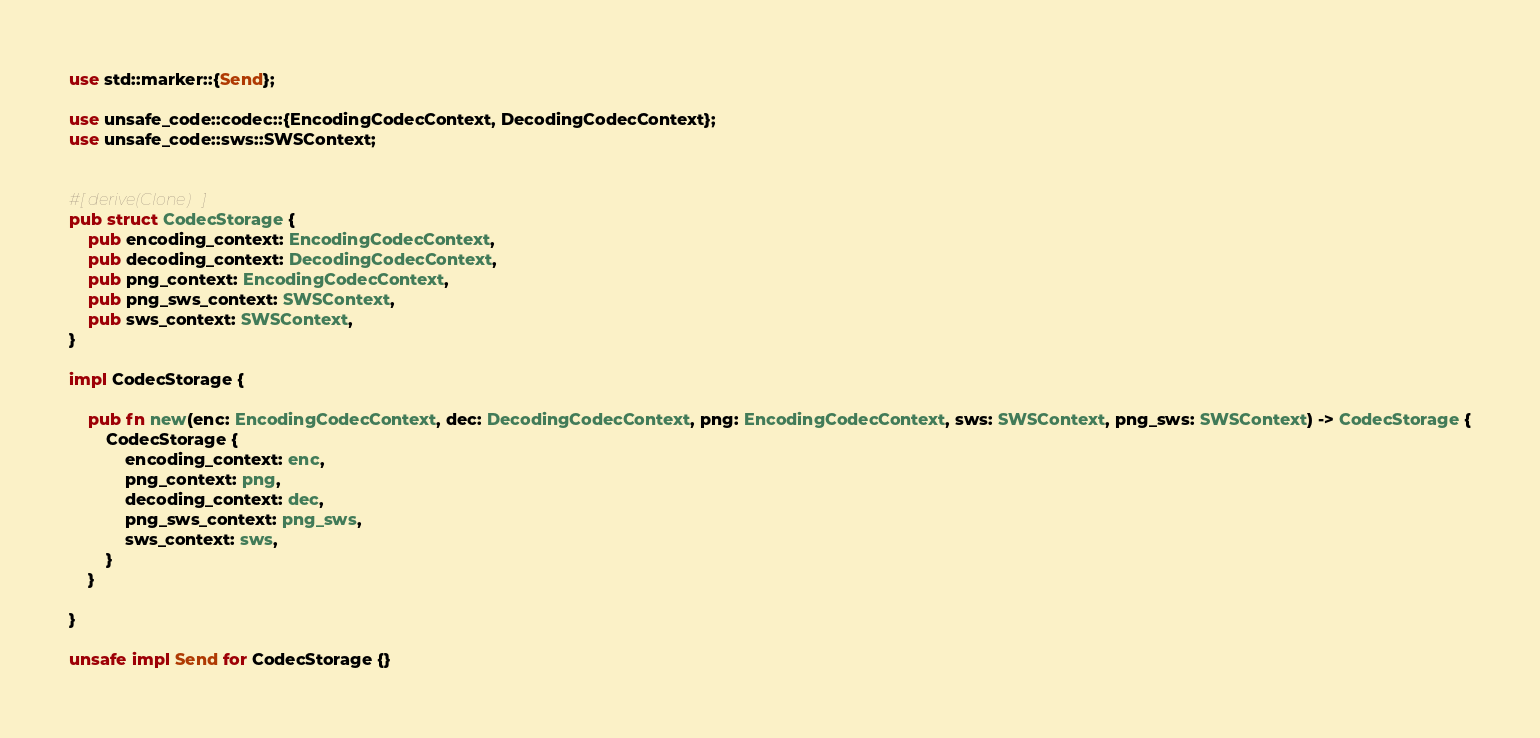Convert code to text. <code><loc_0><loc_0><loc_500><loc_500><_Rust_>use std::marker::{Send};

use unsafe_code::codec::{EncodingCodecContext, DecodingCodecContext};
use unsafe_code::sws::SWSContext;


#[derive(Clone)]
pub struct CodecStorage {
    pub encoding_context: EncodingCodecContext,
    pub decoding_context: DecodingCodecContext,
    pub png_context: EncodingCodecContext,
    pub png_sws_context: SWSContext,
    pub sws_context: SWSContext,
}

impl CodecStorage {

    pub fn new(enc: EncodingCodecContext, dec: DecodingCodecContext, png: EncodingCodecContext, sws: SWSContext, png_sws: SWSContext) -> CodecStorage {
        CodecStorage {
            encoding_context: enc,
            png_context: png,
            decoding_context: dec,
            png_sws_context: png_sws,
            sws_context: sws,
        }
    }

}

unsafe impl Send for CodecStorage {}</code> 